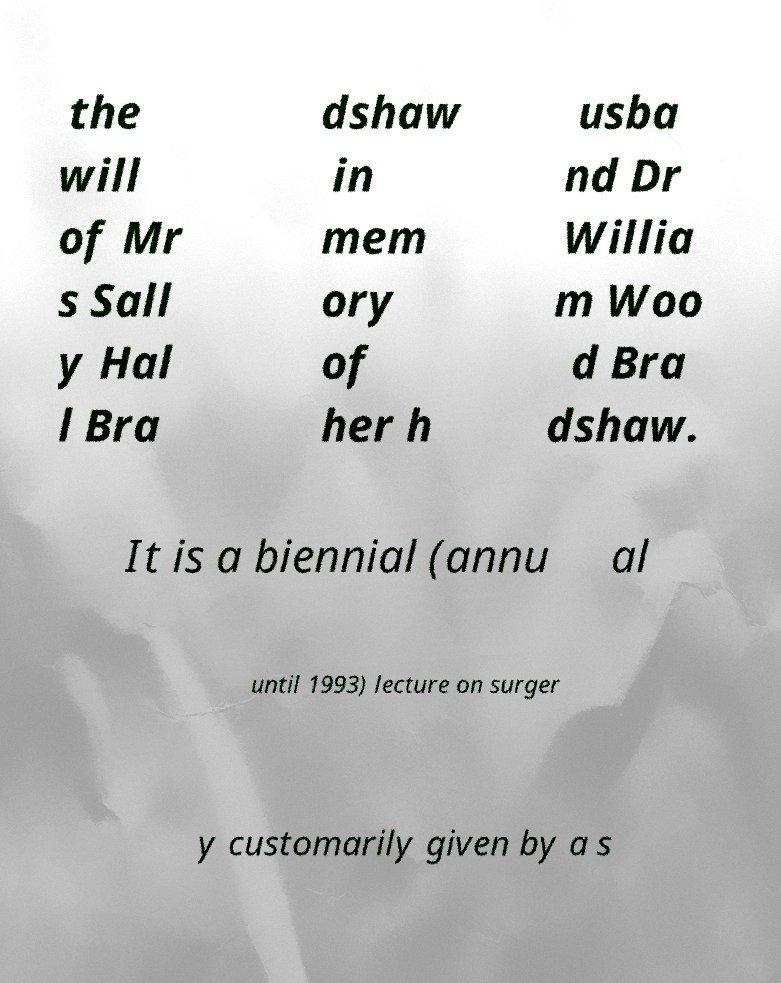Could you assist in decoding the text presented in this image and type it out clearly? the will of Mr s Sall y Hal l Bra dshaw in mem ory of her h usba nd Dr Willia m Woo d Bra dshaw. It is a biennial (annu al until 1993) lecture on surger y customarily given by a s 